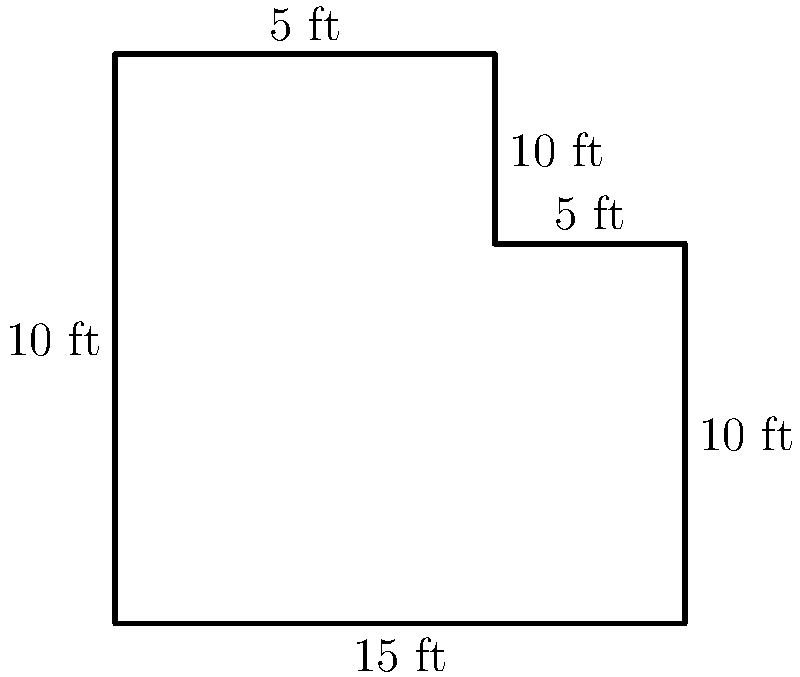As a plumber, you're tasked with installing baseboards in an L-shaped bathroom. Given the floor plan dimensions shown in the diagram, calculate the perimeter of the bathroom to determine the total length of baseboard needed. Round your answer to the nearest foot. To find the perimeter of the L-shaped bathroom, we need to add up all the side lengths:

1. Start with the bottom horizontal side: 15 ft
2. Right vertical side: 10 ft
3. Upper right horizontal side: 5 ft
4. Upper vertical side: 5 ft
5. Left vertical side: 15 ft
6. Left horizontal side: 10 ft

Now, let's add all these lengths:

$$15 + 10 + 5 + 5 + 15 + 10 = 60\text{ ft}$$

The total perimeter is exactly 60 feet, so no rounding is necessary.

As an experienced plumber who values high-quality tools, you'd want to measure this precisely to ensure you have the correct amount of baseboard material, accounting for any cuts or joints needed at the corners.
Answer: 60 ft 